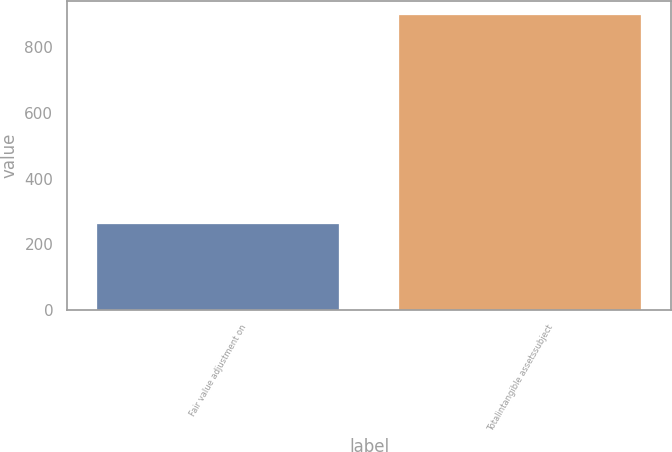Convert chart to OTSL. <chart><loc_0><loc_0><loc_500><loc_500><bar_chart><fcel>Fair value adjustment on<fcel>Totalintangible assetssubject<nl><fcel>261<fcel>897<nl></chart> 